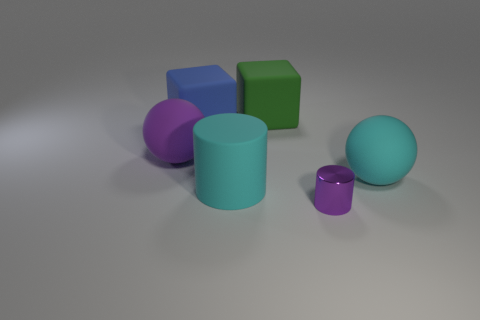How many big blue rubber objects have the same shape as the green matte thing?
Provide a short and direct response. 1. The big blue object that is the same material as the green object is what shape?
Your response must be concise. Cube. What is the color of the big sphere to the right of the large rubber object that is on the left side of the big blue rubber block?
Give a very brief answer. Cyan. The purple object in front of the object that is on the right side of the small purple metal thing is made of what material?
Ensure brevity in your answer.  Metal. There is another big cyan thing that is the same shape as the shiny object; what material is it?
Provide a succinct answer. Rubber. There is a rubber sphere left of the ball that is in front of the purple ball; are there any small metallic objects on the right side of it?
Offer a very short reply. Yes. What number of things are both behind the cyan rubber cylinder and right of the blue thing?
Give a very brief answer. 2. The big purple thing is what shape?
Keep it short and to the point. Sphere. How many other things are there of the same material as the cyan cylinder?
Your answer should be compact. 4. What is the color of the cube that is left of the cyan object that is in front of the large rubber sphere right of the blue thing?
Keep it short and to the point. Blue. 